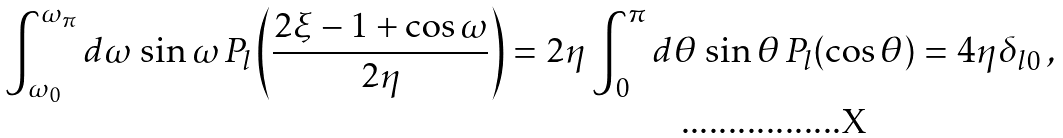Convert formula to latex. <formula><loc_0><loc_0><loc_500><loc_500>\int _ { \omega _ { 0 } } ^ { \omega _ { \pi } } d \omega \, \sin \omega \, P _ { l } \left ( \frac { 2 \xi - 1 + \cos \omega } { 2 \eta } \right ) = 2 \eta \int _ { 0 } ^ { \pi } d \theta \, \sin \theta \, P _ { l } ( \cos \theta ) = 4 \eta \delta _ { l 0 } \, ,</formula> 